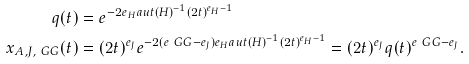Convert formula to latex. <formula><loc_0><loc_0><loc_500><loc_500>q ( t ) & = e ^ { - 2 e _ { H } a u t ( H ) ^ { - 1 } ( 2 t ) ^ { e _ { H } - 1 } } \\ x _ { A , J , \ G G } ( t ) & = ( 2 t ) ^ { e _ { J } } e ^ { - 2 ( e _ { \ } G G - e _ { J } ) e _ { H } a u t ( H ) ^ { - 1 } ( 2 t ) ^ { e _ { H } - 1 } } = ( 2 t ) ^ { e _ { J } } q ( t ) ^ { e _ { \ } G G - e _ { J } } .</formula> 